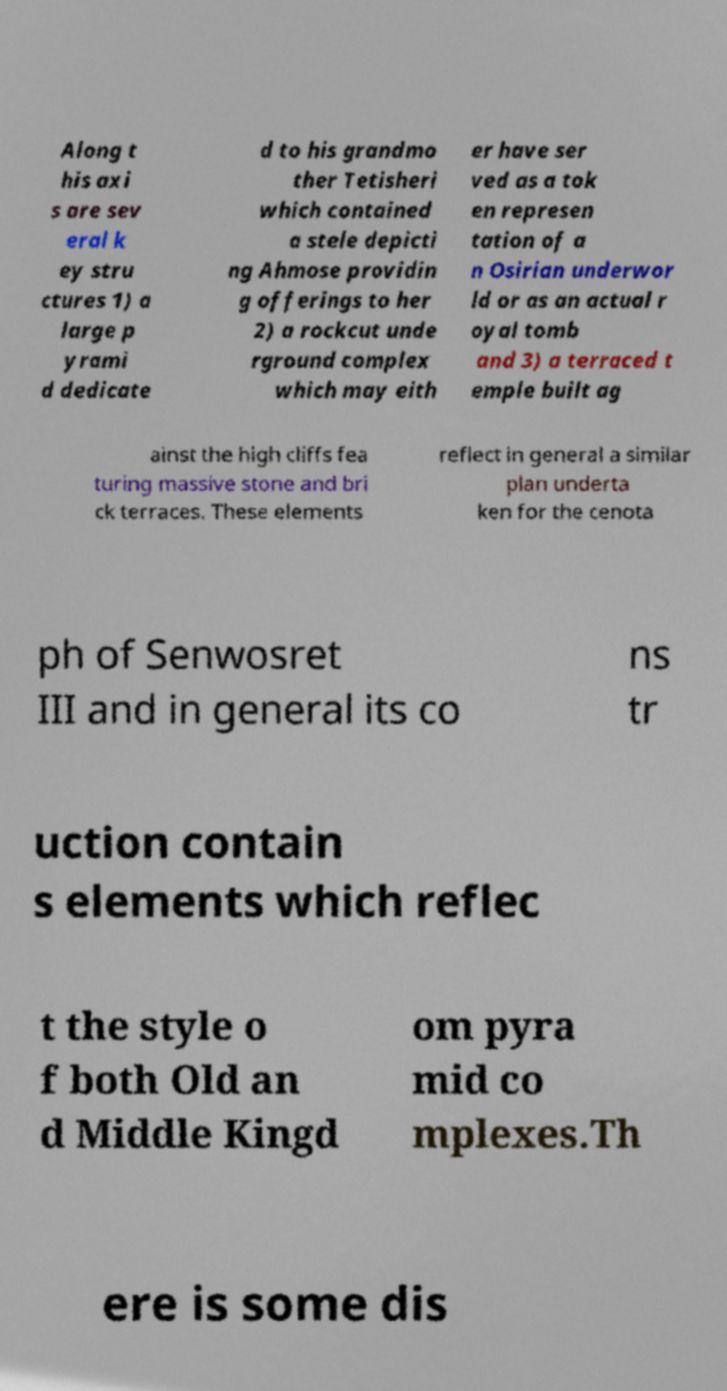There's text embedded in this image that I need extracted. Can you transcribe it verbatim? Along t his axi s are sev eral k ey stru ctures 1) a large p yrami d dedicate d to his grandmo ther Tetisheri which contained a stele depicti ng Ahmose providin g offerings to her 2) a rockcut unde rground complex which may eith er have ser ved as a tok en represen tation of a n Osirian underwor ld or as an actual r oyal tomb and 3) a terraced t emple built ag ainst the high cliffs fea turing massive stone and bri ck terraces. These elements reflect in general a similar plan underta ken for the cenota ph of Senwosret III and in general its co ns tr uction contain s elements which reflec t the style o f both Old an d Middle Kingd om pyra mid co mplexes.Th ere is some dis 